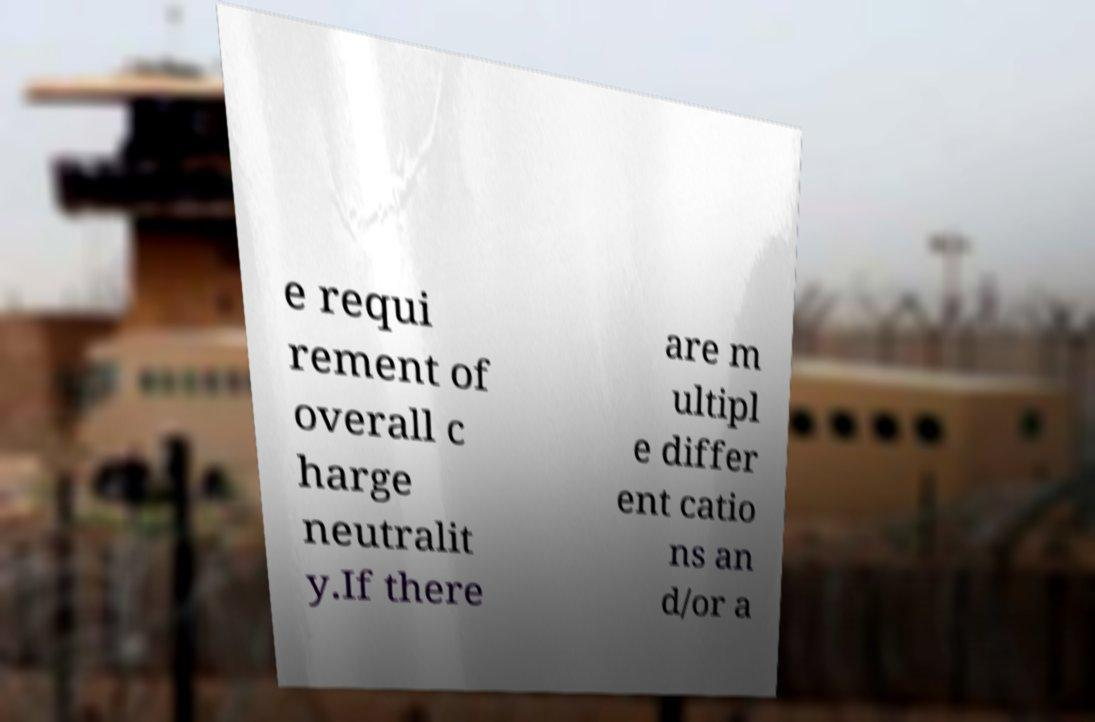I need the written content from this picture converted into text. Can you do that? e requi rement of overall c harge neutralit y.If there are m ultipl e differ ent catio ns an d/or a 